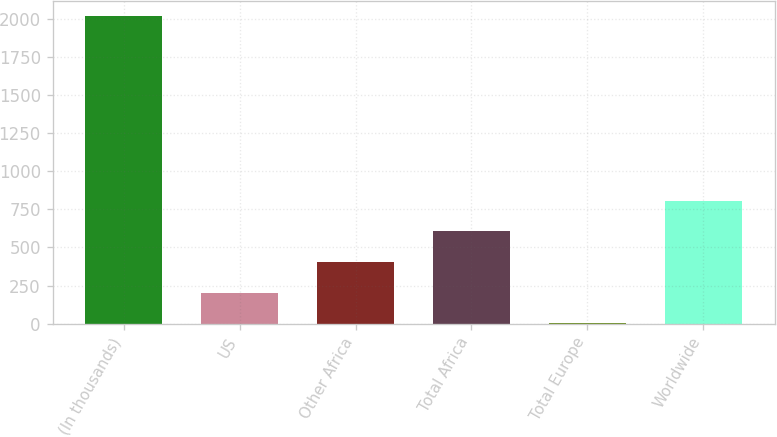Convert chart to OTSL. <chart><loc_0><loc_0><loc_500><loc_500><bar_chart><fcel>(In thousands)<fcel>US<fcel>Other Africa<fcel>Total Africa<fcel>Total Europe<fcel>Worldwide<nl><fcel>2016<fcel>202.5<fcel>404<fcel>605.5<fcel>1<fcel>807<nl></chart> 